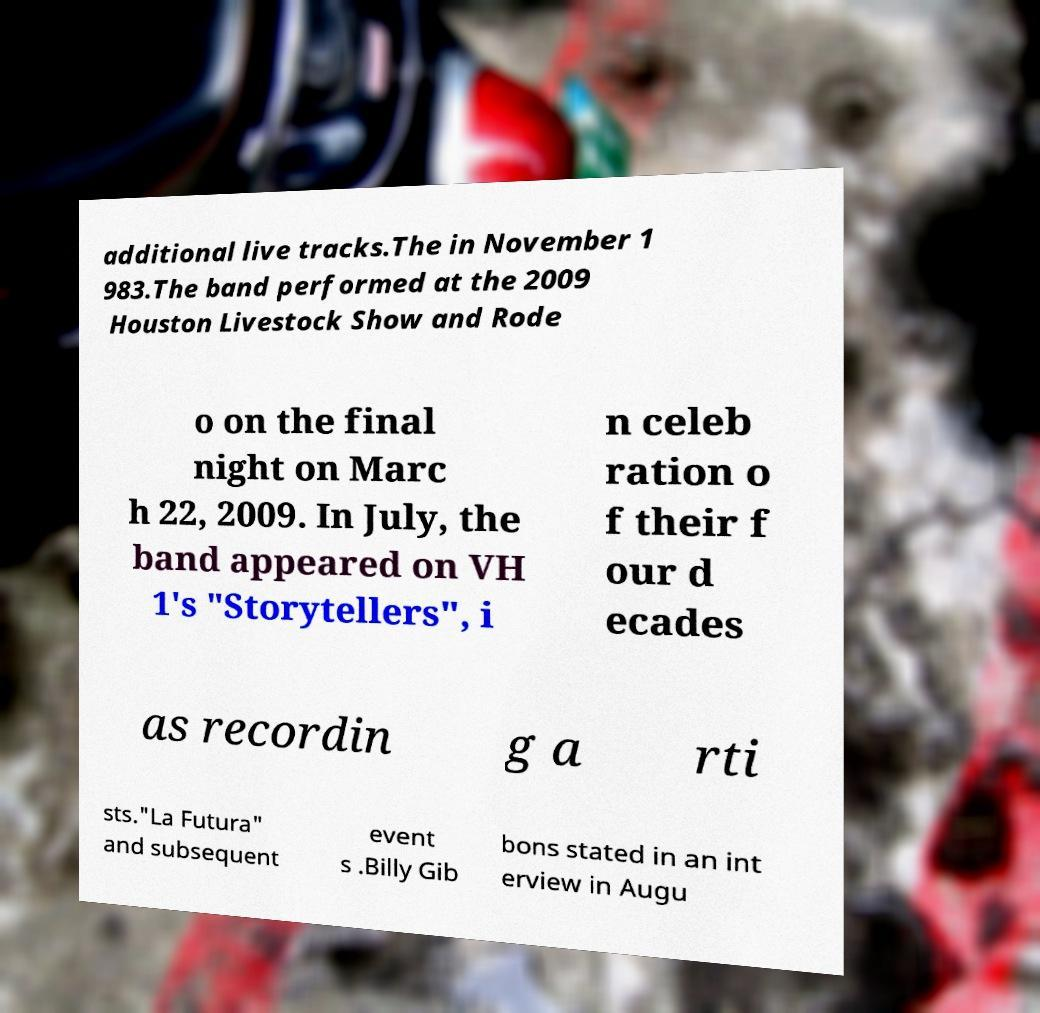Can you accurately transcribe the text from the provided image for me? additional live tracks.The in November 1 983.The band performed at the 2009 Houston Livestock Show and Rode o on the final night on Marc h 22, 2009. In July, the band appeared on VH 1's "Storytellers", i n celeb ration o f their f our d ecades as recordin g a rti sts."La Futura" and subsequent event s .Billy Gib bons stated in an int erview in Augu 